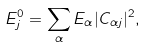<formula> <loc_0><loc_0><loc_500><loc_500>E _ { j } ^ { 0 } = \sum _ { \alpha } E _ { \alpha } | C _ { \alpha j } | ^ { 2 } ,</formula> 